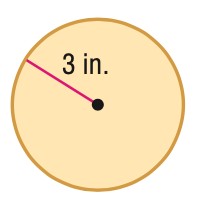Question: Find the circumference of the figure. Round to the nearest tenth.
Choices:
A. 9.4
B. 18.8
C. 28.3
D. 37.7
Answer with the letter. Answer: B 